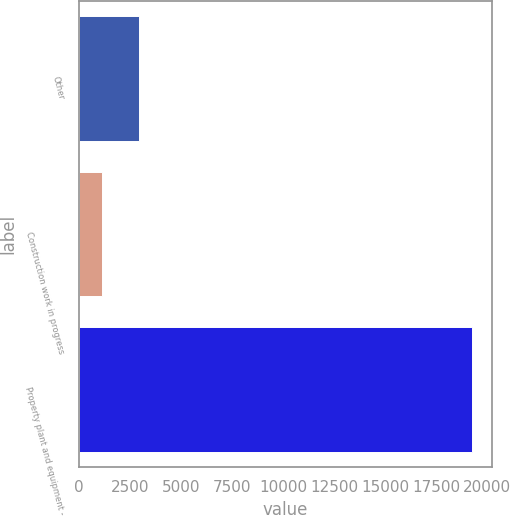Convert chart. <chart><loc_0><loc_0><loc_500><loc_500><bar_chart><fcel>Other<fcel>Construction work in progress<fcel>Property plant and equipment -<nl><fcel>2946<fcel>1134<fcel>19254<nl></chart> 